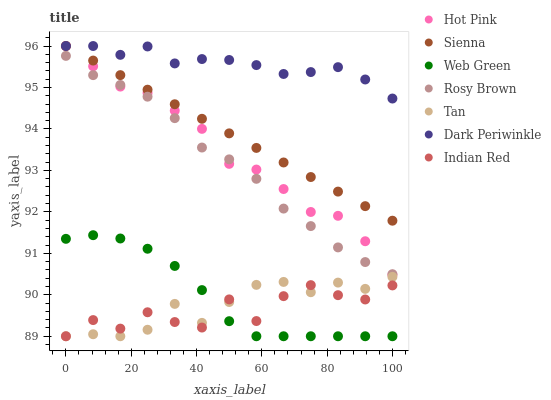Does Indian Red have the minimum area under the curve?
Answer yes or no. Yes. Does Dark Periwinkle have the maximum area under the curve?
Answer yes or no. Yes. Does Rosy Brown have the minimum area under the curve?
Answer yes or no. No. Does Rosy Brown have the maximum area under the curve?
Answer yes or no. No. Is Sienna the smoothest?
Answer yes or no. Yes. Is Indian Red the roughest?
Answer yes or no. Yes. Is Rosy Brown the smoothest?
Answer yes or no. No. Is Rosy Brown the roughest?
Answer yes or no. No. Does Web Green have the lowest value?
Answer yes or no. Yes. Does Rosy Brown have the lowest value?
Answer yes or no. No. Does Dark Periwinkle have the highest value?
Answer yes or no. Yes. Does Rosy Brown have the highest value?
Answer yes or no. No. Is Tan less than Rosy Brown?
Answer yes or no. Yes. Is Rosy Brown greater than Indian Red?
Answer yes or no. Yes. Does Web Green intersect Indian Red?
Answer yes or no. Yes. Is Web Green less than Indian Red?
Answer yes or no. No. Is Web Green greater than Indian Red?
Answer yes or no. No. Does Tan intersect Rosy Brown?
Answer yes or no. No. 